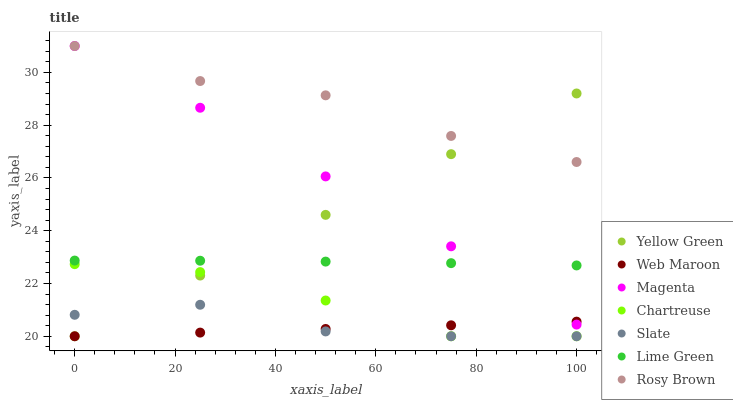Does Web Maroon have the minimum area under the curve?
Answer yes or no. Yes. Does Rosy Brown have the maximum area under the curve?
Answer yes or no. Yes. Does Slate have the minimum area under the curve?
Answer yes or no. No. Does Slate have the maximum area under the curve?
Answer yes or no. No. Is Yellow Green the smoothest?
Answer yes or no. Yes. Is Chartreuse the roughest?
Answer yes or no. Yes. Is Slate the smoothest?
Answer yes or no. No. Is Slate the roughest?
Answer yes or no. No. Does Yellow Green have the lowest value?
Answer yes or no. Yes. Does Rosy Brown have the lowest value?
Answer yes or no. No. Does Magenta have the highest value?
Answer yes or no. Yes. Does Slate have the highest value?
Answer yes or no. No. Is Web Maroon less than Lime Green?
Answer yes or no. Yes. Is Magenta greater than Slate?
Answer yes or no. Yes. Does Lime Green intersect Magenta?
Answer yes or no. Yes. Is Lime Green less than Magenta?
Answer yes or no. No. Is Lime Green greater than Magenta?
Answer yes or no. No. Does Web Maroon intersect Lime Green?
Answer yes or no. No. 